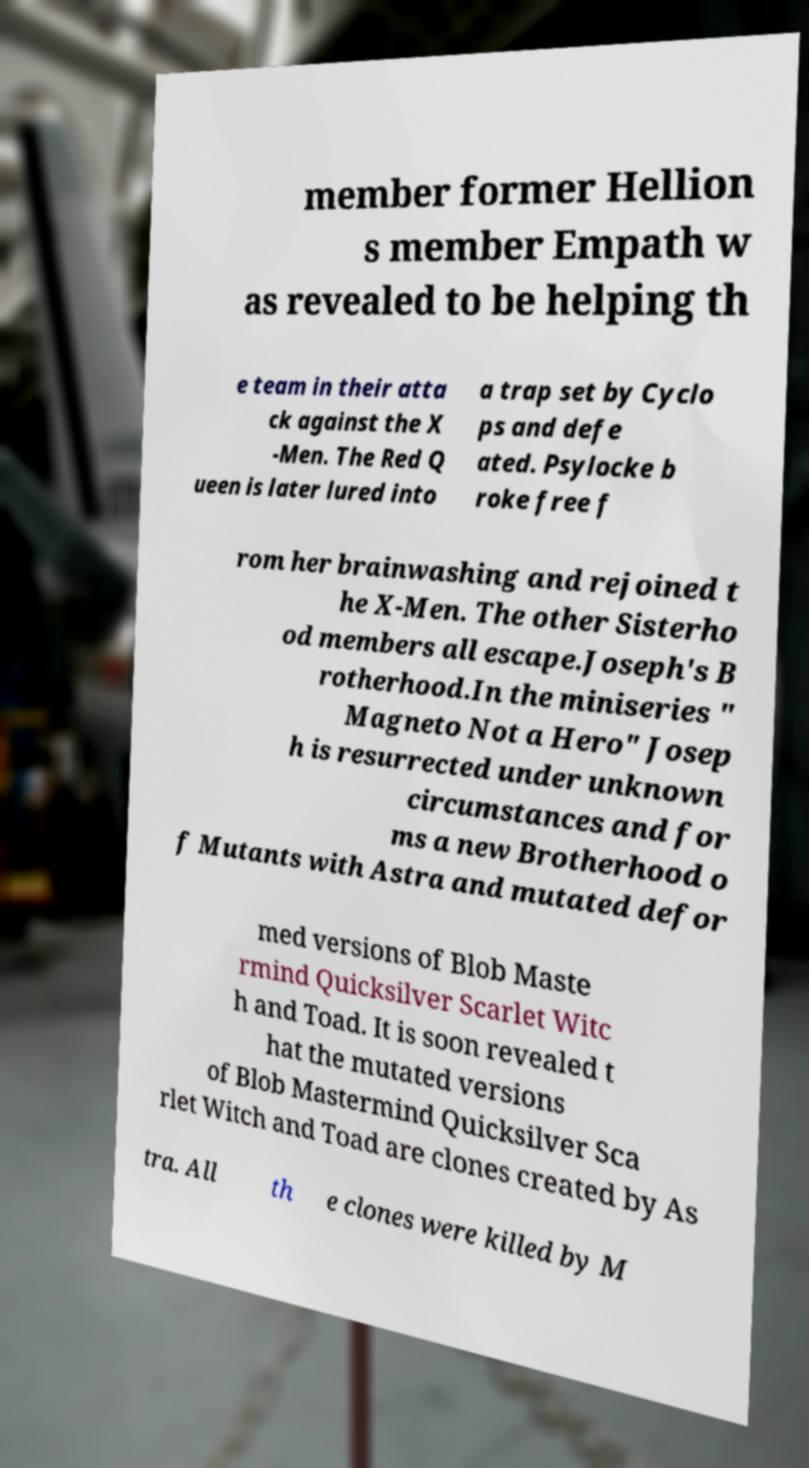I need the written content from this picture converted into text. Can you do that? member former Hellion s member Empath w as revealed to be helping th e team in their atta ck against the X -Men. The Red Q ueen is later lured into a trap set by Cyclo ps and defe ated. Psylocke b roke free f rom her brainwashing and rejoined t he X-Men. The other Sisterho od members all escape.Joseph's B rotherhood.In the miniseries " Magneto Not a Hero" Josep h is resurrected under unknown circumstances and for ms a new Brotherhood o f Mutants with Astra and mutated defor med versions of Blob Maste rmind Quicksilver Scarlet Witc h and Toad. It is soon revealed t hat the mutated versions of Blob Mastermind Quicksilver Sca rlet Witch and Toad are clones created by As tra. All th e clones were killed by M 